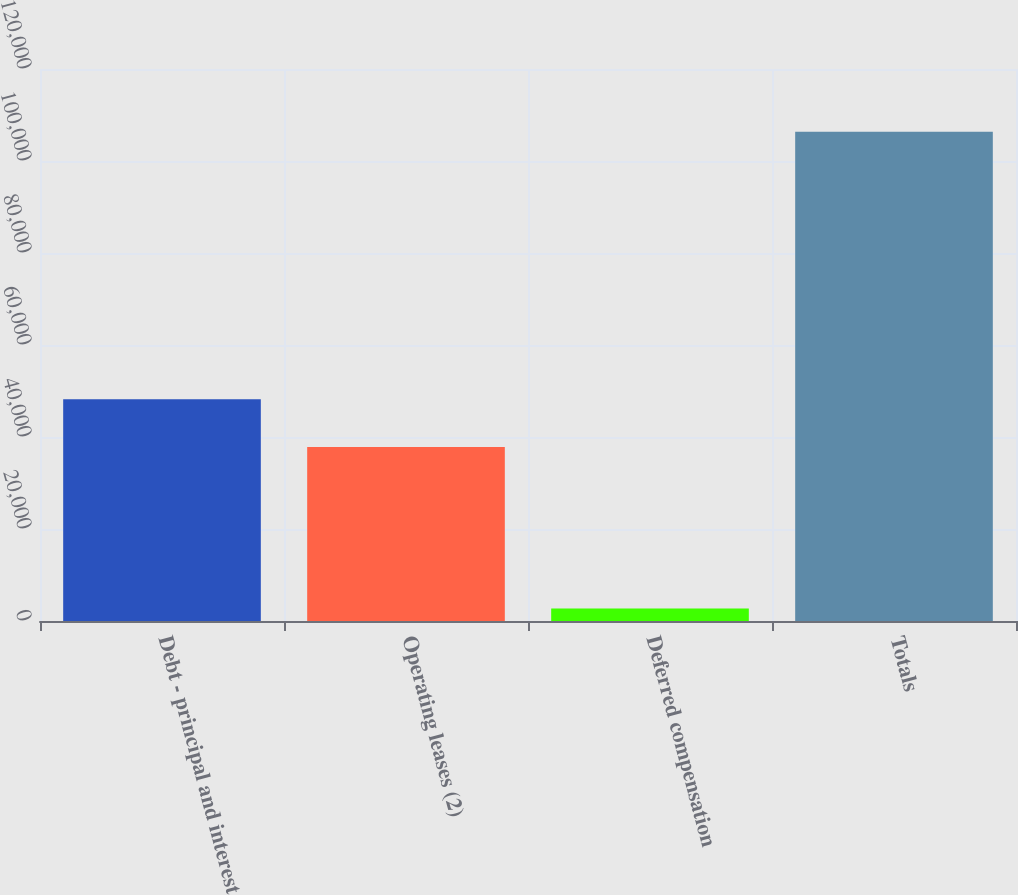Convert chart to OTSL. <chart><loc_0><loc_0><loc_500><loc_500><bar_chart><fcel>Debt - principal and interest<fcel>Operating leases (2)<fcel>Deferred compensation<fcel>Totals<nl><fcel>48184.5<fcel>37820<fcel>2730<fcel>106375<nl></chart> 